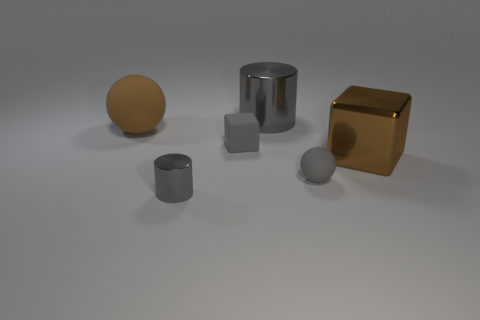How many tiny gray things are there?
Provide a short and direct response. 3. Is there a metal thing that has the same color as the large ball?
Make the answer very short. Yes. What color is the cylinder in front of the brown thing that is left of the object that is behind the large brown matte thing?
Your answer should be compact. Gray. Does the big sphere have the same material as the small gray thing that is behind the big shiny cube?
Offer a very short reply. Yes. What is the material of the brown ball?
Your answer should be very brief. Rubber. There is a ball that is the same color as the shiny cube; what material is it?
Your response must be concise. Rubber. How many other things are there of the same material as the brown block?
Your answer should be very brief. 2. What shape is the object that is right of the large brown rubber ball and on the left side of the rubber cube?
Your answer should be very brief. Cylinder. What color is the big cube that is the same material as the big gray cylinder?
Provide a succinct answer. Brown. Are there the same number of tiny gray shiny things that are on the right side of the gray ball and matte objects?
Your response must be concise. No. 